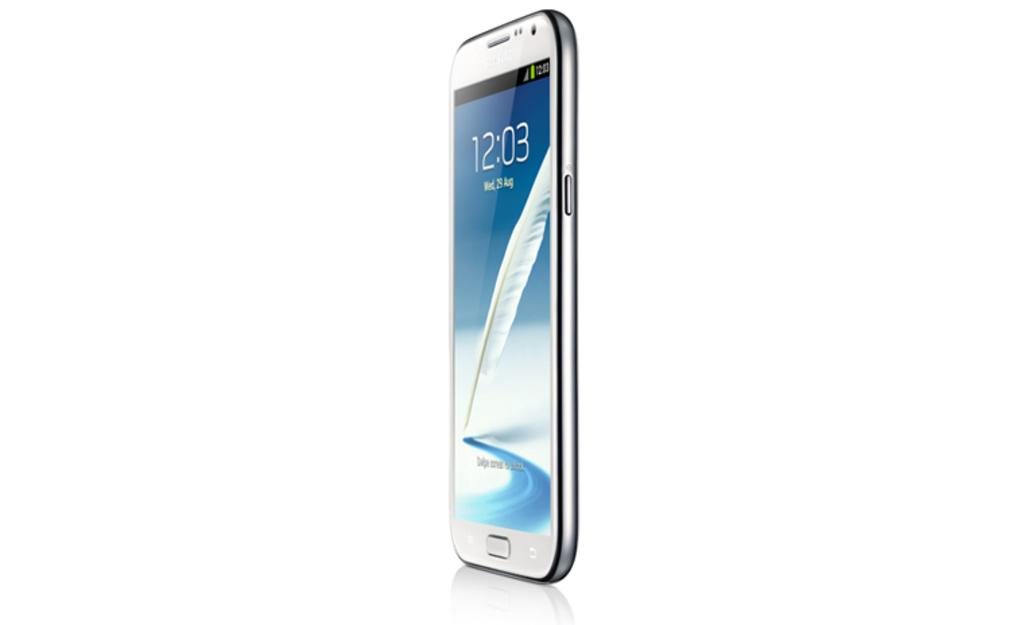<image>
Offer a succinct explanation of the picture presented. A standing phone displays the time as 12:03. 